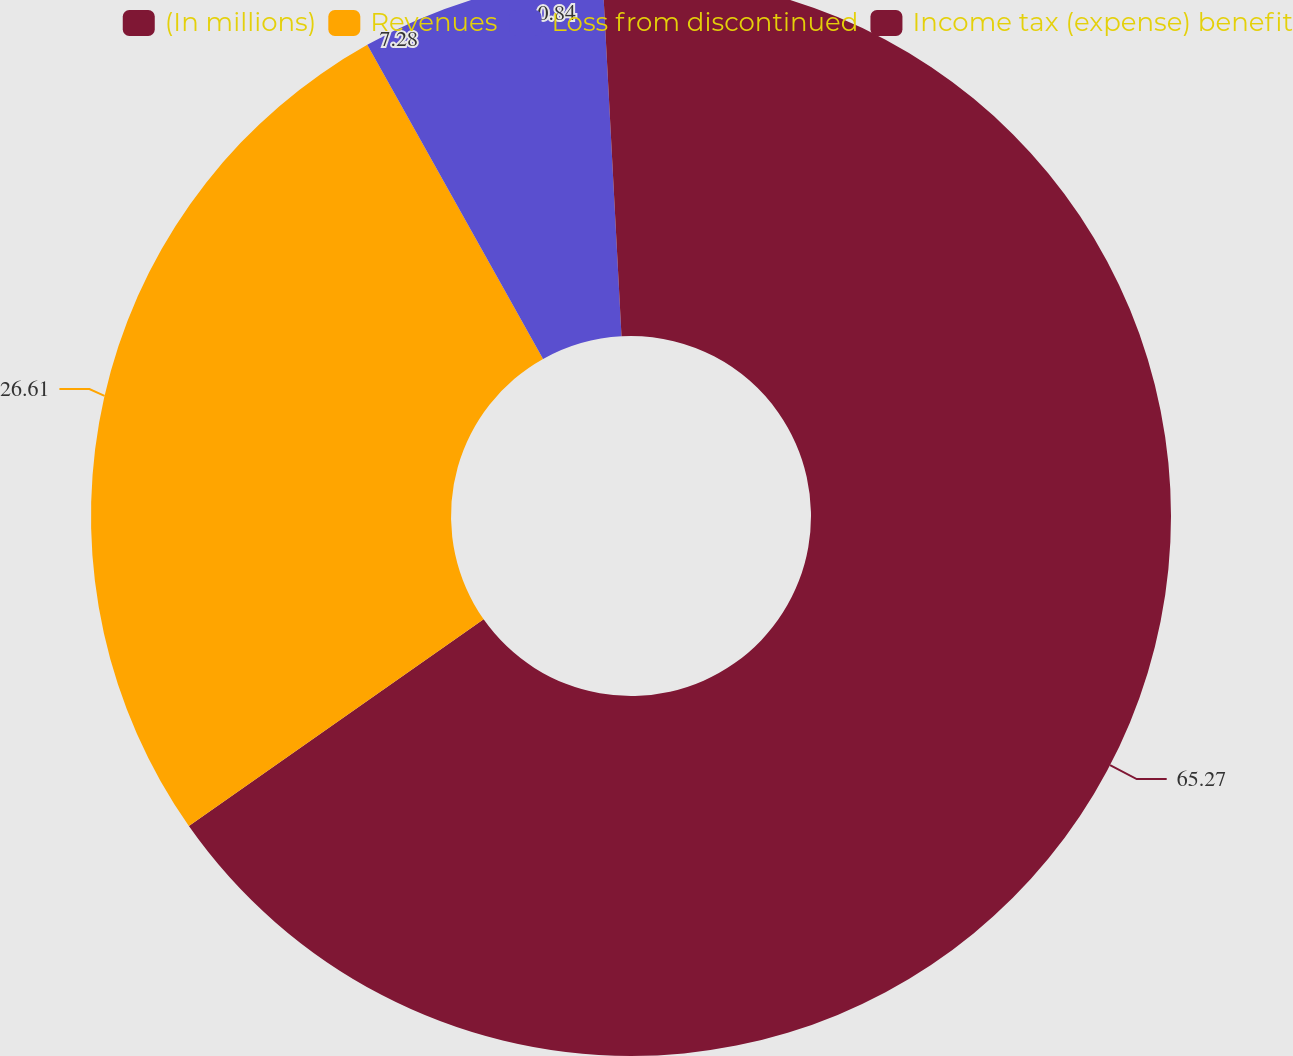Convert chart. <chart><loc_0><loc_0><loc_500><loc_500><pie_chart><fcel>(In millions)<fcel>Revenues<fcel>Loss from discontinued<fcel>Income tax (expense) benefit<nl><fcel>65.26%<fcel>26.61%<fcel>7.28%<fcel>0.84%<nl></chart> 